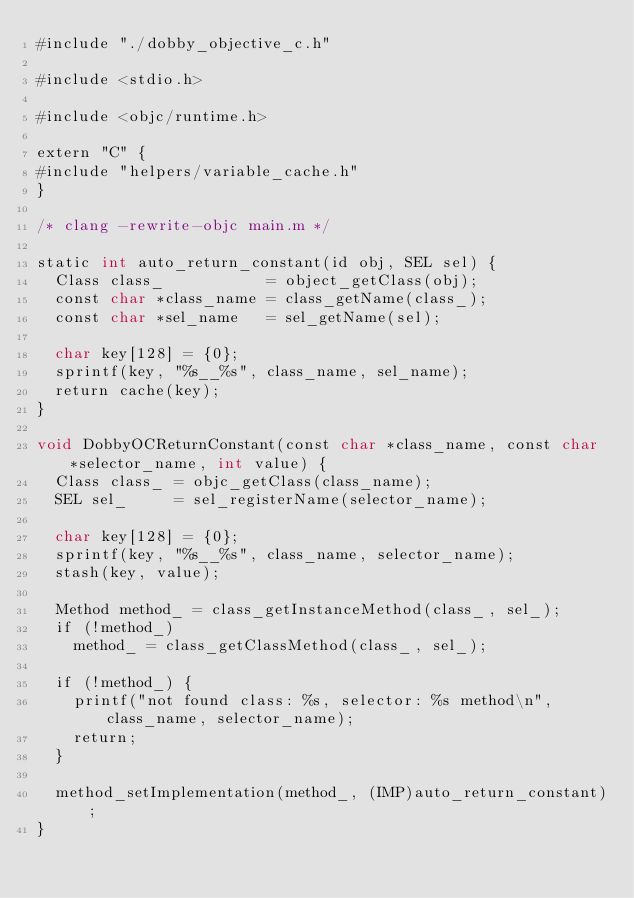<code> <loc_0><loc_0><loc_500><loc_500><_ObjectiveC_>#include "./dobby_objective_c.h"

#include <stdio.h>

#include <objc/runtime.h>

extern "C" {
#include "helpers/variable_cache.h"
}

/* clang -rewrite-objc main.m */

static int auto_return_constant(id obj, SEL sel) {
  Class class_           = object_getClass(obj);
  const char *class_name = class_getName(class_);
  const char *sel_name   = sel_getName(sel);

  char key[128] = {0};
  sprintf(key, "%s__%s", class_name, sel_name);
  return cache(key);
}

void DobbyOCReturnConstant(const char *class_name, const char *selector_name, int value) {
  Class class_ = objc_getClass(class_name);
  SEL sel_     = sel_registerName(selector_name);

  char key[128] = {0};
  sprintf(key, "%s__%s", class_name, selector_name);
  stash(key, value);

  Method method_ = class_getInstanceMethod(class_, sel_);
  if (!method_)
    method_ = class_getClassMethod(class_, sel_);

  if (!method_) {
    printf("not found class: %s, selector: %s method\n", class_name, selector_name);
    return;
  }

  method_setImplementation(method_, (IMP)auto_return_constant);
}
</code> 